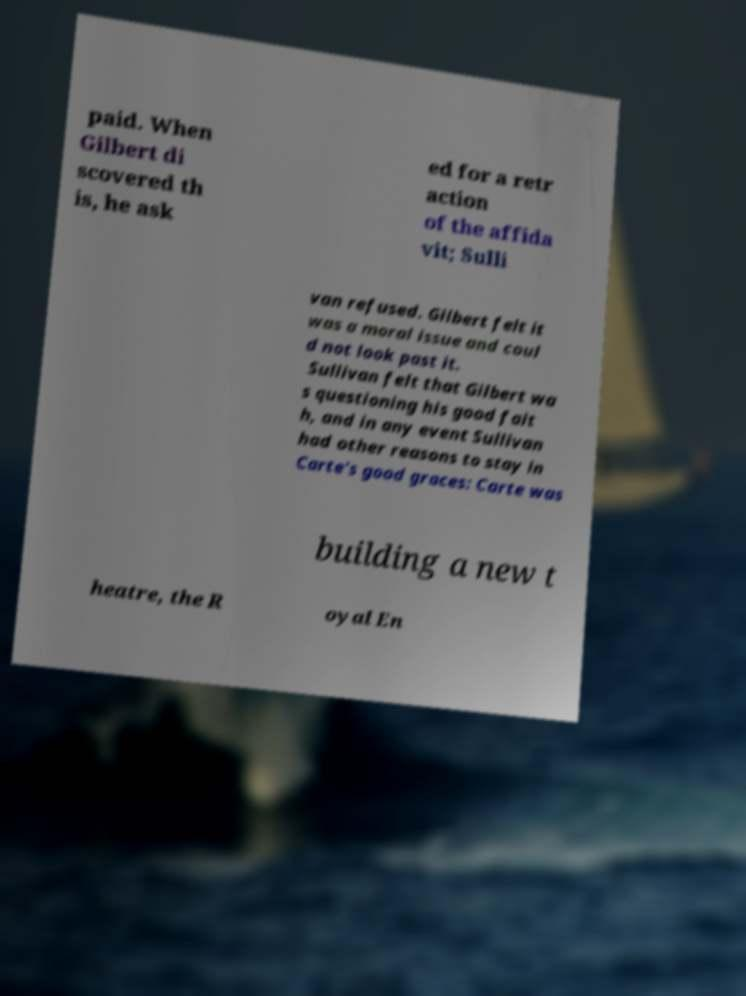Please identify and transcribe the text found in this image. paid. When Gilbert di scovered th is, he ask ed for a retr action of the affida vit; Sulli van refused. Gilbert felt it was a moral issue and coul d not look past it. Sullivan felt that Gilbert wa s questioning his good fait h, and in any event Sullivan had other reasons to stay in Carte's good graces: Carte was building a new t heatre, the R oyal En 